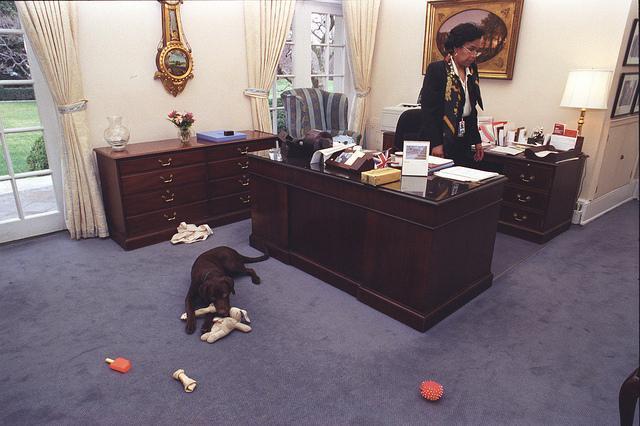How many people are there?
Give a very brief answer. 1. 